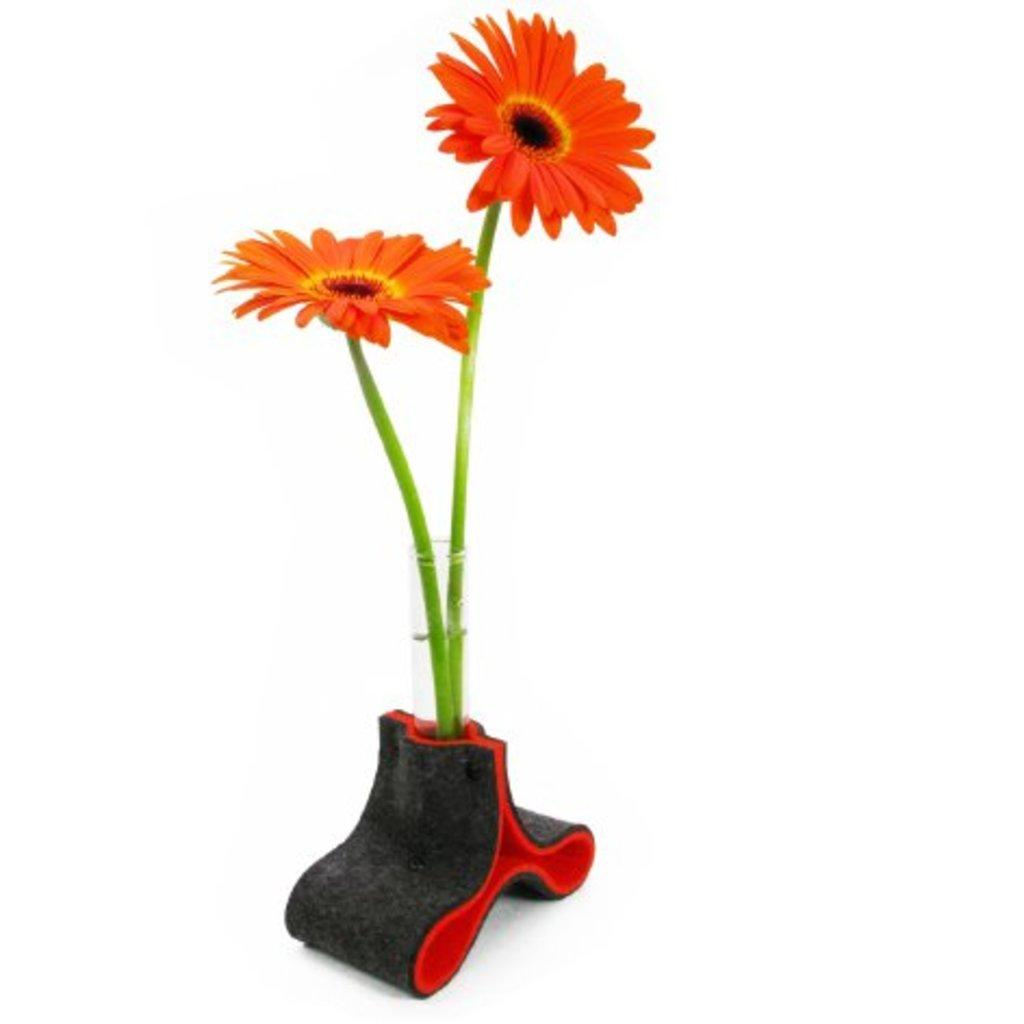How many flowers are in the image? There are two orange color flowers in the image. What is the flowers placed in? The flowers are in a vase. Where is the vase located? The vase is on a surface. What is the opinion of the sun about the flowers in the image? The sun does not have an opinion, as it is a celestial body and not capable of forming opinions. 